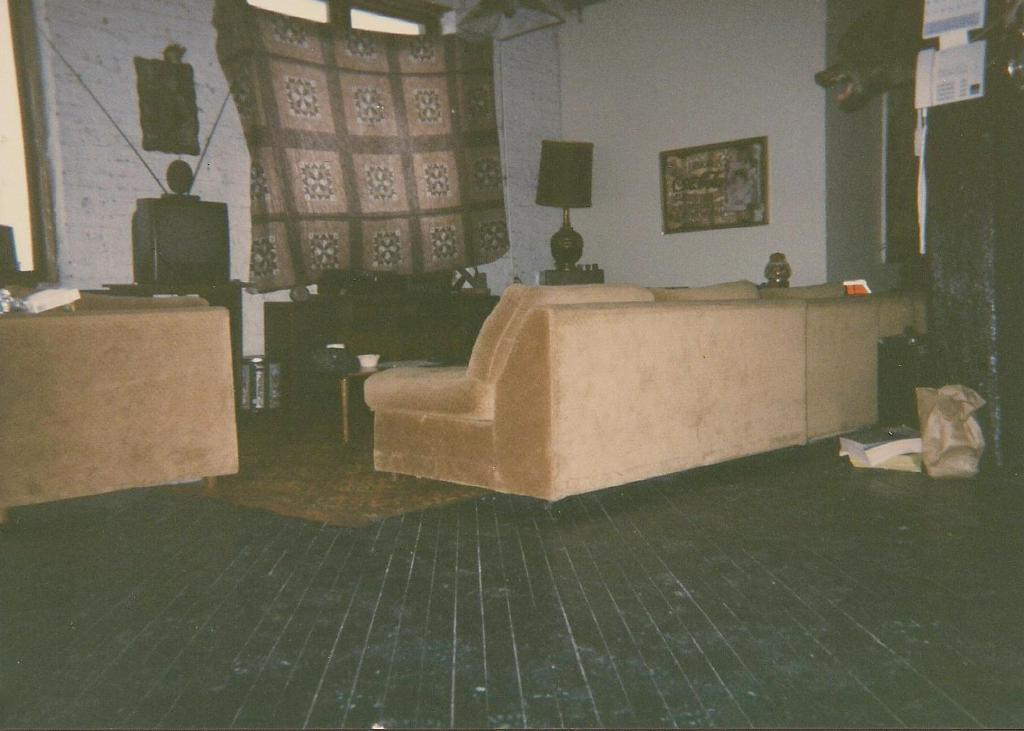Could you give a brief overview of what you see in this image? In the image there are two sofas. In front of them there is a table with objects on it. Below the table there is a floor mat. There is a television on the table. And also there is a table with a lamp. In the background there is a wall with windows and curtains and also there are frames. On the right corner of the image there is an object with few items hanging on it. And also there is a statue of an animal. And on the floor there are few things. 